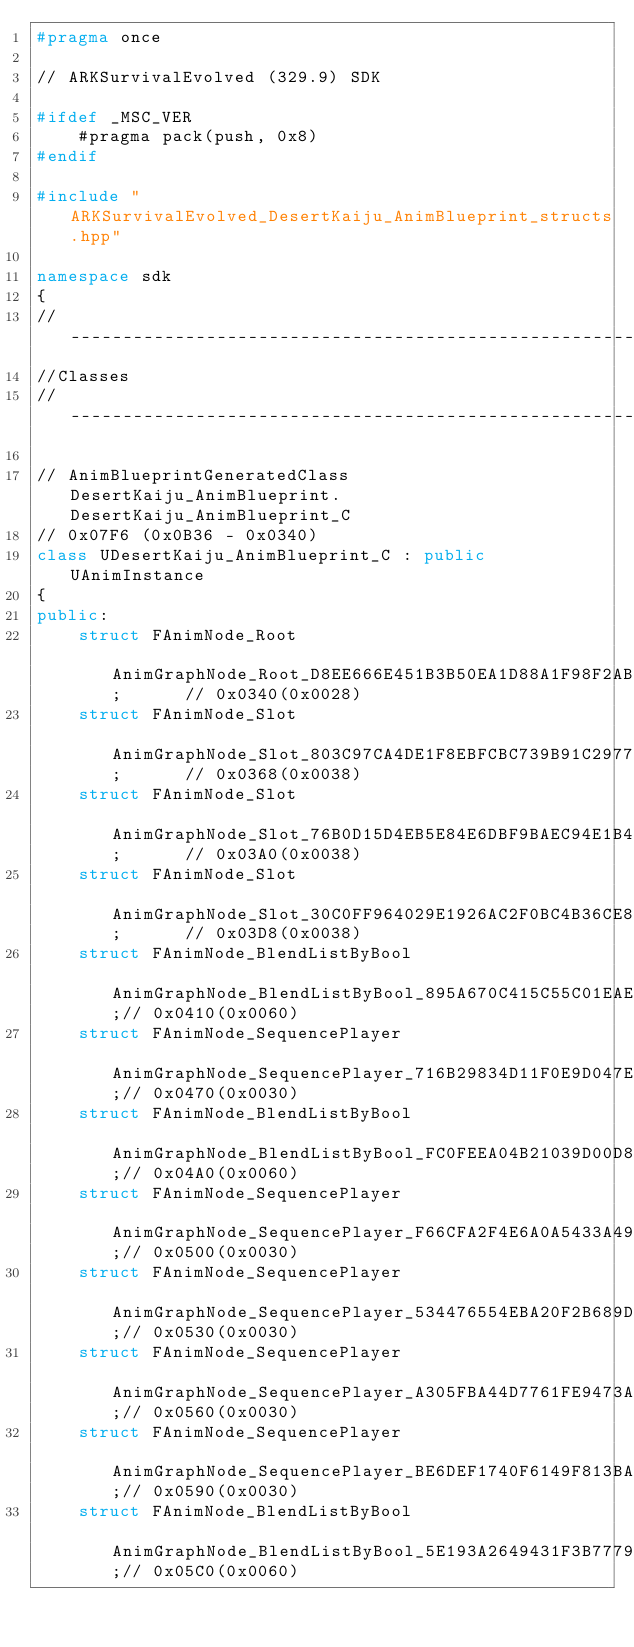<code> <loc_0><loc_0><loc_500><loc_500><_C++_>#pragma once

// ARKSurvivalEvolved (329.9) SDK

#ifdef _MSC_VER
	#pragma pack(push, 0x8)
#endif

#include "ARKSurvivalEvolved_DesertKaiju_AnimBlueprint_structs.hpp"

namespace sdk
{
//---------------------------------------------------------------------------
//Classes
//---------------------------------------------------------------------------

// AnimBlueprintGeneratedClass DesertKaiju_AnimBlueprint.DesertKaiju_AnimBlueprint_C
// 0x07F6 (0x0B36 - 0x0340)
class UDesertKaiju_AnimBlueprint_C : public UAnimInstance
{
public:
	struct FAnimNode_Root                              AnimGraphNode_Root_D8EE666E451B3B50EA1D88A1F98F2AB3;      // 0x0340(0x0028)
	struct FAnimNode_Slot                              AnimGraphNode_Slot_803C97CA4DE1F8EBFCBC739B91C2977F;      // 0x0368(0x0038)
	struct FAnimNode_Slot                              AnimGraphNode_Slot_76B0D15D4EB5E84E6DBF9BAEC94E1B47;      // 0x03A0(0x0038)
	struct FAnimNode_Slot                              AnimGraphNode_Slot_30C0FF964029E1926AC2F0BC4B36CE8E;      // 0x03D8(0x0038)
	struct FAnimNode_BlendListByBool                   AnimGraphNode_BlendListByBool_895A670C415C55C01EAE6DBE4489BF2C;// 0x0410(0x0060)
	struct FAnimNode_SequencePlayer                    AnimGraphNode_SequencePlayer_716B29834D11F0E9D047E28C96669B88;// 0x0470(0x0030)
	struct FAnimNode_BlendListByBool                   AnimGraphNode_BlendListByBool_FC0FEEA04B21039D00D8B1BAF68DE5DE;// 0x04A0(0x0060)
	struct FAnimNode_SequencePlayer                    AnimGraphNode_SequencePlayer_F66CFA2F4E6A0A5433A492B66622393D;// 0x0500(0x0030)
	struct FAnimNode_SequencePlayer                    AnimGraphNode_SequencePlayer_534476554EBA20F2B689D5A2DAF190F7;// 0x0530(0x0030)
	struct FAnimNode_SequencePlayer                    AnimGraphNode_SequencePlayer_A305FBA44D7761FE9473ACA9127A04BC;// 0x0560(0x0030)
	struct FAnimNode_SequencePlayer                    AnimGraphNode_SequencePlayer_BE6DEF1740F6149F813BAA8588FA2AD3;// 0x0590(0x0030)
	struct FAnimNode_BlendListByBool                   AnimGraphNode_BlendListByBool_5E193A2649431F3B7779AB811E9E88D5;// 0x05C0(0x0060)</code> 